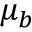Convert formula to latex. <formula><loc_0><loc_0><loc_500><loc_500>\mu _ { b }</formula> 